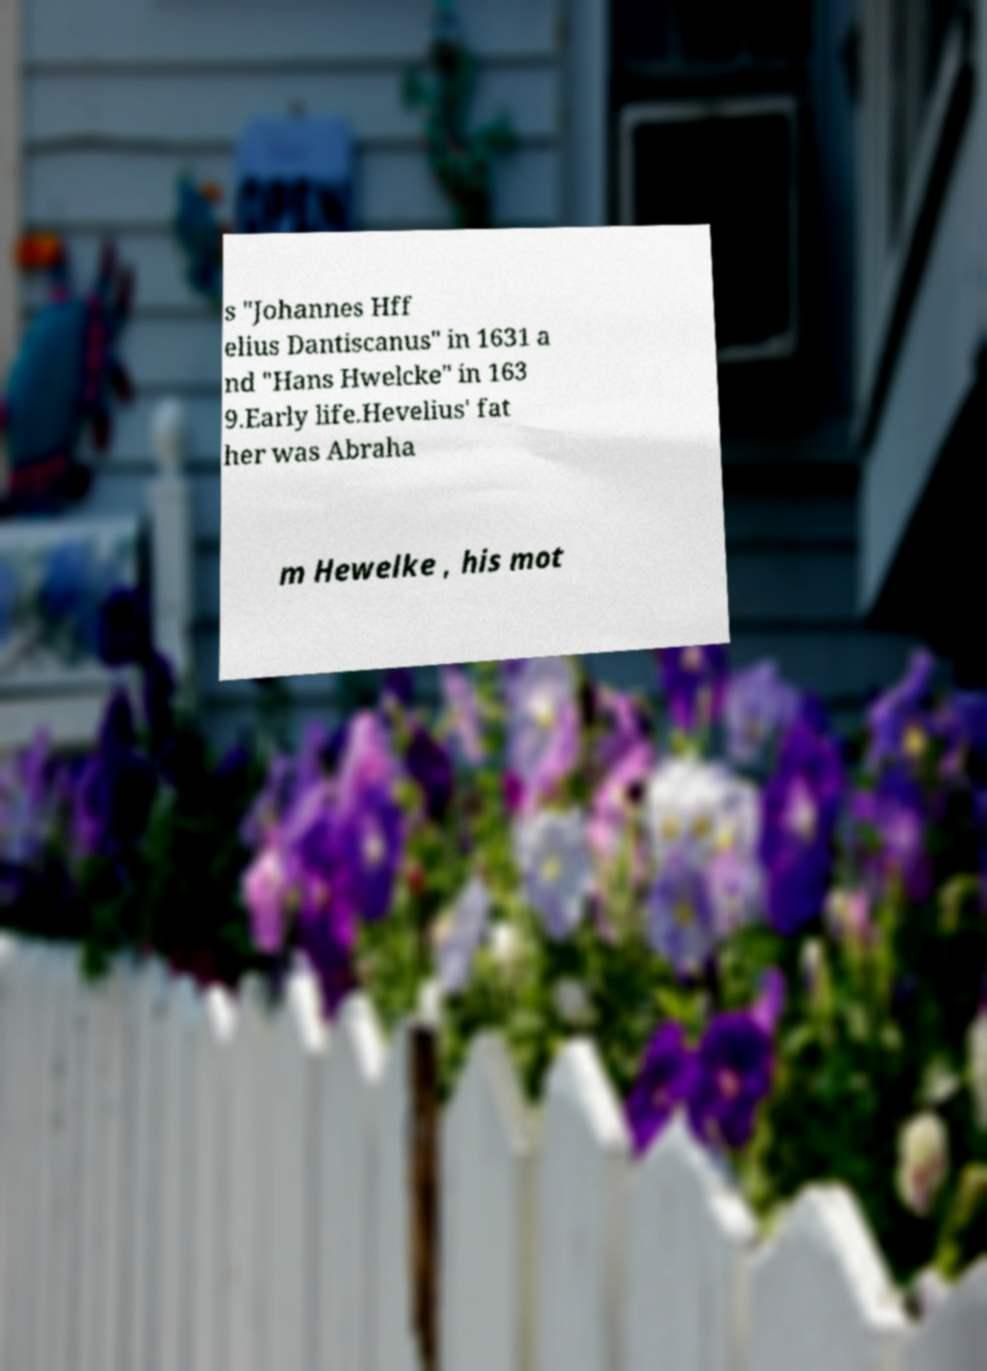I need the written content from this picture converted into text. Can you do that? s "Johannes Hff elius Dantiscanus" in 1631 a nd "Hans Hwelcke" in 163 9.Early life.Hevelius' fat her was Abraha m Hewelke , his mot 